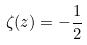<formula> <loc_0><loc_0><loc_500><loc_500>\zeta ( z ) = - \frac { 1 } { 2 }</formula> 